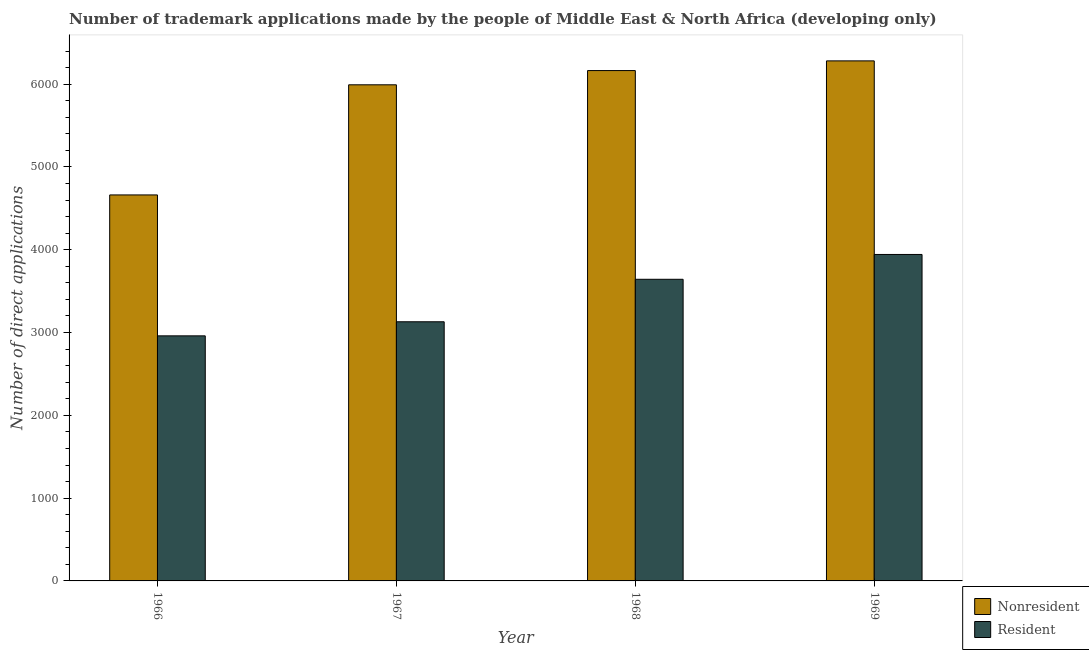How many different coloured bars are there?
Make the answer very short. 2. Are the number of bars on each tick of the X-axis equal?
Offer a very short reply. Yes. How many bars are there on the 3rd tick from the right?
Provide a short and direct response. 2. What is the label of the 2nd group of bars from the left?
Your answer should be compact. 1967. What is the number of trademark applications made by residents in 1966?
Ensure brevity in your answer.  2960. Across all years, what is the maximum number of trademark applications made by non residents?
Offer a terse response. 6281. Across all years, what is the minimum number of trademark applications made by non residents?
Provide a short and direct response. 4662. In which year was the number of trademark applications made by non residents maximum?
Ensure brevity in your answer.  1969. In which year was the number of trademark applications made by residents minimum?
Provide a short and direct response. 1966. What is the total number of trademark applications made by non residents in the graph?
Offer a very short reply. 2.31e+04. What is the difference between the number of trademark applications made by non residents in 1967 and that in 1968?
Keep it short and to the point. -172. What is the difference between the number of trademark applications made by non residents in 1969 and the number of trademark applications made by residents in 1966?
Ensure brevity in your answer.  1619. What is the average number of trademark applications made by non residents per year?
Offer a very short reply. 5774.75. In the year 1969, what is the difference between the number of trademark applications made by non residents and number of trademark applications made by residents?
Your answer should be compact. 0. What is the ratio of the number of trademark applications made by non residents in 1966 to that in 1967?
Provide a short and direct response. 0.78. Is the number of trademark applications made by non residents in 1966 less than that in 1968?
Provide a short and direct response. Yes. Is the difference between the number of trademark applications made by residents in 1967 and 1969 greater than the difference between the number of trademark applications made by non residents in 1967 and 1969?
Your answer should be compact. No. What is the difference between the highest and the second highest number of trademark applications made by residents?
Provide a succinct answer. 300. What is the difference between the highest and the lowest number of trademark applications made by residents?
Your response must be concise. 983. In how many years, is the number of trademark applications made by non residents greater than the average number of trademark applications made by non residents taken over all years?
Offer a terse response. 3. Is the sum of the number of trademark applications made by residents in 1967 and 1968 greater than the maximum number of trademark applications made by non residents across all years?
Provide a succinct answer. Yes. What does the 2nd bar from the left in 1969 represents?
Your answer should be compact. Resident. What does the 1st bar from the right in 1967 represents?
Provide a short and direct response. Resident. Are all the bars in the graph horizontal?
Offer a very short reply. No. What is the difference between two consecutive major ticks on the Y-axis?
Keep it short and to the point. 1000. Does the graph contain any zero values?
Your answer should be compact. No. Does the graph contain grids?
Keep it short and to the point. No. How many legend labels are there?
Keep it short and to the point. 2. What is the title of the graph?
Your answer should be compact. Number of trademark applications made by the people of Middle East & North Africa (developing only). Does "Fixed telephone" appear as one of the legend labels in the graph?
Keep it short and to the point. No. What is the label or title of the X-axis?
Offer a terse response. Year. What is the label or title of the Y-axis?
Give a very brief answer. Number of direct applications. What is the Number of direct applications of Nonresident in 1966?
Offer a very short reply. 4662. What is the Number of direct applications in Resident in 1966?
Provide a short and direct response. 2960. What is the Number of direct applications in Nonresident in 1967?
Offer a very short reply. 5992. What is the Number of direct applications of Resident in 1967?
Your answer should be compact. 3130. What is the Number of direct applications of Nonresident in 1968?
Your response must be concise. 6164. What is the Number of direct applications in Resident in 1968?
Your response must be concise. 3643. What is the Number of direct applications in Nonresident in 1969?
Provide a short and direct response. 6281. What is the Number of direct applications of Resident in 1969?
Offer a terse response. 3943. Across all years, what is the maximum Number of direct applications in Nonresident?
Ensure brevity in your answer.  6281. Across all years, what is the maximum Number of direct applications of Resident?
Keep it short and to the point. 3943. Across all years, what is the minimum Number of direct applications in Nonresident?
Offer a very short reply. 4662. Across all years, what is the minimum Number of direct applications of Resident?
Your answer should be compact. 2960. What is the total Number of direct applications of Nonresident in the graph?
Provide a short and direct response. 2.31e+04. What is the total Number of direct applications of Resident in the graph?
Your response must be concise. 1.37e+04. What is the difference between the Number of direct applications of Nonresident in 1966 and that in 1967?
Provide a succinct answer. -1330. What is the difference between the Number of direct applications in Resident in 1966 and that in 1967?
Ensure brevity in your answer.  -170. What is the difference between the Number of direct applications of Nonresident in 1966 and that in 1968?
Give a very brief answer. -1502. What is the difference between the Number of direct applications of Resident in 1966 and that in 1968?
Provide a succinct answer. -683. What is the difference between the Number of direct applications in Nonresident in 1966 and that in 1969?
Offer a terse response. -1619. What is the difference between the Number of direct applications of Resident in 1966 and that in 1969?
Ensure brevity in your answer.  -983. What is the difference between the Number of direct applications in Nonresident in 1967 and that in 1968?
Your response must be concise. -172. What is the difference between the Number of direct applications in Resident in 1967 and that in 1968?
Ensure brevity in your answer.  -513. What is the difference between the Number of direct applications of Nonresident in 1967 and that in 1969?
Your answer should be compact. -289. What is the difference between the Number of direct applications in Resident in 1967 and that in 1969?
Make the answer very short. -813. What is the difference between the Number of direct applications in Nonresident in 1968 and that in 1969?
Provide a succinct answer. -117. What is the difference between the Number of direct applications of Resident in 1968 and that in 1969?
Offer a very short reply. -300. What is the difference between the Number of direct applications in Nonresident in 1966 and the Number of direct applications in Resident in 1967?
Provide a short and direct response. 1532. What is the difference between the Number of direct applications of Nonresident in 1966 and the Number of direct applications of Resident in 1968?
Provide a succinct answer. 1019. What is the difference between the Number of direct applications in Nonresident in 1966 and the Number of direct applications in Resident in 1969?
Your answer should be very brief. 719. What is the difference between the Number of direct applications in Nonresident in 1967 and the Number of direct applications in Resident in 1968?
Offer a terse response. 2349. What is the difference between the Number of direct applications of Nonresident in 1967 and the Number of direct applications of Resident in 1969?
Keep it short and to the point. 2049. What is the difference between the Number of direct applications of Nonresident in 1968 and the Number of direct applications of Resident in 1969?
Keep it short and to the point. 2221. What is the average Number of direct applications in Nonresident per year?
Your answer should be compact. 5774.75. What is the average Number of direct applications in Resident per year?
Your answer should be very brief. 3419. In the year 1966, what is the difference between the Number of direct applications of Nonresident and Number of direct applications of Resident?
Make the answer very short. 1702. In the year 1967, what is the difference between the Number of direct applications of Nonresident and Number of direct applications of Resident?
Ensure brevity in your answer.  2862. In the year 1968, what is the difference between the Number of direct applications in Nonresident and Number of direct applications in Resident?
Keep it short and to the point. 2521. In the year 1969, what is the difference between the Number of direct applications of Nonresident and Number of direct applications of Resident?
Your answer should be compact. 2338. What is the ratio of the Number of direct applications in Nonresident in 1966 to that in 1967?
Provide a succinct answer. 0.78. What is the ratio of the Number of direct applications of Resident in 1966 to that in 1967?
Offer a terse response. 0.95. What is the ratio of the Number of direct applications in Nonresident in 1966 to that in 1968?
Keep it short and to the point. 0.76. What is the ratio of the Number of direct applications of Resident in 1966 to that in 1968?
Your answer should be very brief. 0.81. What is the ratio of the Number of direct applications of Nonresident in 1966 to that in 1969?
Offer a very short reply. 0.74. What is the ratio of the Number of direct applications of Resident in 1966 to that in 1969?
Make the answer very short. 0.75. What is the ratio of the Number of direct applications in Nonresident in 1967 to that in 1968?
Offer a terse response. 0.97. What is the ratio of the Number of direct applications in Resident in 1967 to that in 1968?
Provide a succinct answer. 0.86. What is the ratio of the Number of direct applications of Nonresident in 1967 to that in 1969?
Offer a terse response. 0.95. What is the ratio of the Number of direct applications in Resident in 1967 to that in 1969?
Offer a very short reply. 0.79. What is the ratio of the Number of direct applications in Nonresident in 1968 to that in 1969?
Provide a short and direct response. 0.98. What is the ratio of the Number of direct applications in Resident in 1968 to that in 1969?
Your answer should be very brief. 0.92. What is the difference between the highest and the second highest Number of direct applications in Nonresident?
Provide a succinct answer. 117. What is the difference between the highest and the second highest Number of direct applications in Resident?
Ensure brevity in your answer.  300. What is the difference between the highest and the lowest Number of direct applications in Nonresident?
Offer a very short reply. 1619. What is the difference between the highest and the lowest Number of direct applications of Resident?
Keep it short and to the point. 983. 